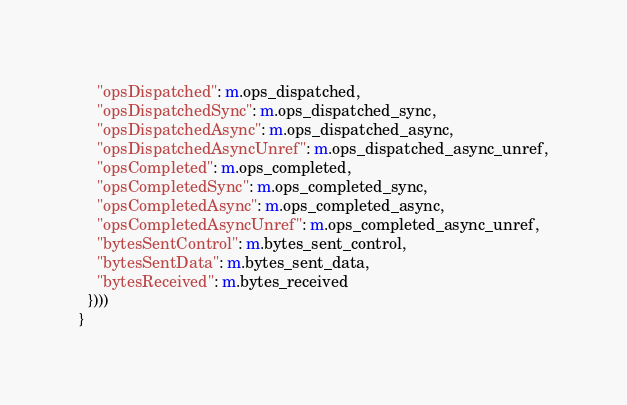<code> <loc_0><loc_0><loc_500><loc_500><_Rust_>    "opsDispatched": m.ops_dispatched,
    "opsDispatchedSync": m.ops_dispatched_sync,
    "opsDispatchedAsync": m.ops_dispatched_async,
    "opsDispatchedAsyncUnref": m.ops_dispatched_async_unref,
    "opsCompleted": m.ops_completed,
    "opsCompletedSync": m.ops_completed_sync,
    "opsCompletedAsync": m.ops_completed_async,
    "opsCompletedAsyncUnref": m.ops_completed_async_unref,
    "bytesSentControl": m.bytes_sent_control,
    "bytesSentData": m.bytes_sent_data,
    "bytesReceived": m.bytes_received
  })))
}
</code> 